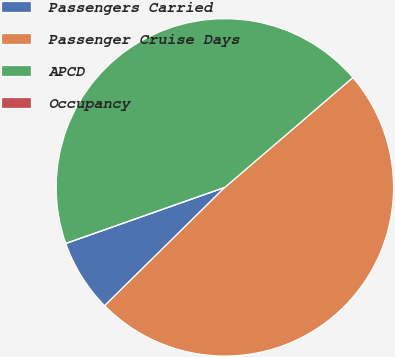<chart> <loc_0><loc_0><loc_500><loc_500><pie_chart><fcel>Passengers Carried<fcel>Passenger Cruise Days<fcel>APCD<fcel>Occupancy<nl><fcel>6.98%<fcel>48.91%<fcel>44.11%<fcel>0.0%<nl></chart> 